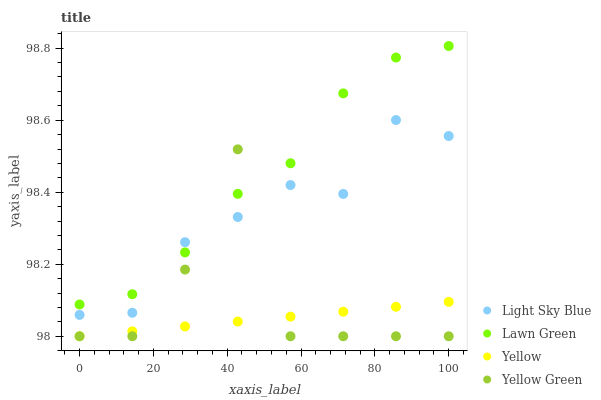Does Yellow have the minimum area under the curve?
Answer yes or no. Yes. Does Lawn Green have the maximum area under the curve?
Answer yes or no. Yes. Does Light Sky Blue have the minimum area under the curve?
Answer yes or no. No. Does Light Sky Blue have the maximum area under the curve?
Answer yes or no. No. Is Yellow the smoothest?
Answer yes or no. Yes. Is Yellow Green the roughest?
Answer yes or no. Yes. Is Light Sky Blue the smoothest?
Answer yes or no. No. Is Light Sky Blue the roughest?
Answer yes or no. No. Does Yellow Green have the lowest value?
Answer yes or no. Yes. Does Light Sky Blue have the lowest value?
Answer yes or no. No. Does Lawn Green have the highest value?
Answer yes or no. Yes. Does Light Sky Blue have the highest value?
Answer yes or no. No. Is Yellow less than Lawn Green?
Answer yes or no. Yes. Is Light Sky Blue greater than Yellow?
Answer yes or no. Yes. Does Yellow intersect Yellow Green?
Answer yes or no. Yes. Is Yellow less than Yellow Green?
Answer yes or no. No. Is Yellow greater than Yellow Green?
Answer yes or no. No. Does Yellow intersect Lawn Green?
Answer yes or no. No. 